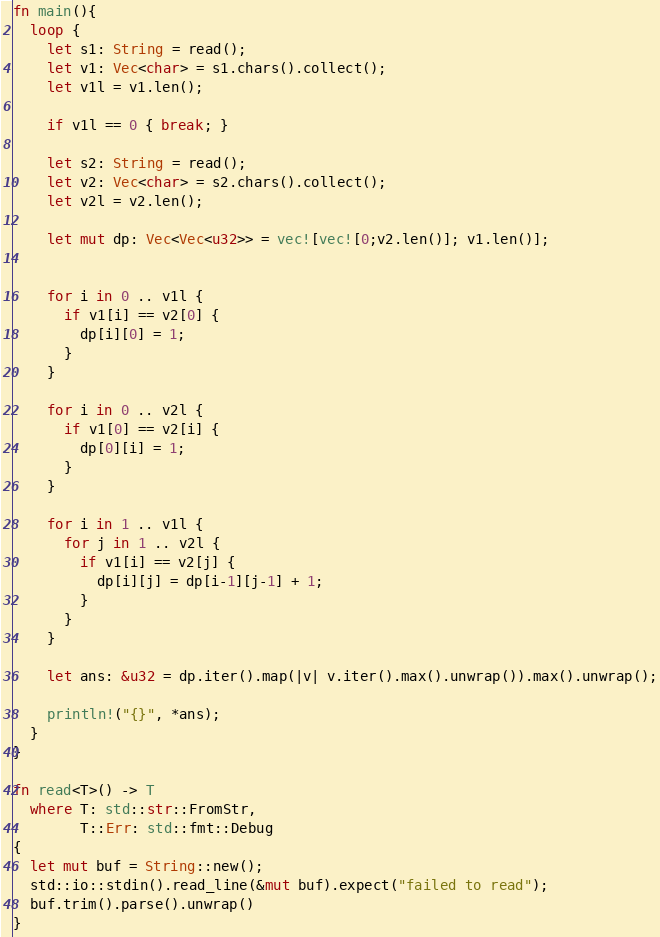Convert code to text. <code><loc_0><loc_0><loc_500><loc_500><_Rust_>fn main(){
  loop {
    let s1: String = read();
    let v1: Vec<char> = s1.chars().collect();
    let v1l = v1.len();

    if v1l == 0 { break; }
    
    let s2: String = read();
    let v2: Vec<char> = s2.chars().collect();
    let v2l = v2.len();

    let mut dp: Vec<Vec<u32>> = vec![vec![0;v2.len()]; v1.len()];

    
    for i in 0 .. v1l {
      if v1[i] == v2[0] {
        dp[i][0] = 1;
      }
    }
    
    for i in 0 .. v2l {
      if v1[0] == v2[i] {
        dp[0][i] = 1;
      }
    }

    for i in 1 .. v1l {
      for j in 1 .. v2l {
        if v1[i] == v2[j] {
          dp[i][j] = dp[i-1][j-1] + 1;
        }
      }
    }

    let ans: &u32 = dp.iter().map(|v| v.iter().max().unwrap()).max().unwrap();
    
    println!("{}", *ans);
  }
}

fn read<T>() -> T
  where T: std::str::FromStr,
        T::Err: std::fmt::Debug
{
  let mut buf = String::new();
  std::io::stdin().read_line(&mut buf).expect("failed to read");
  buf.trim().parse().unwrap()
}

</code> 